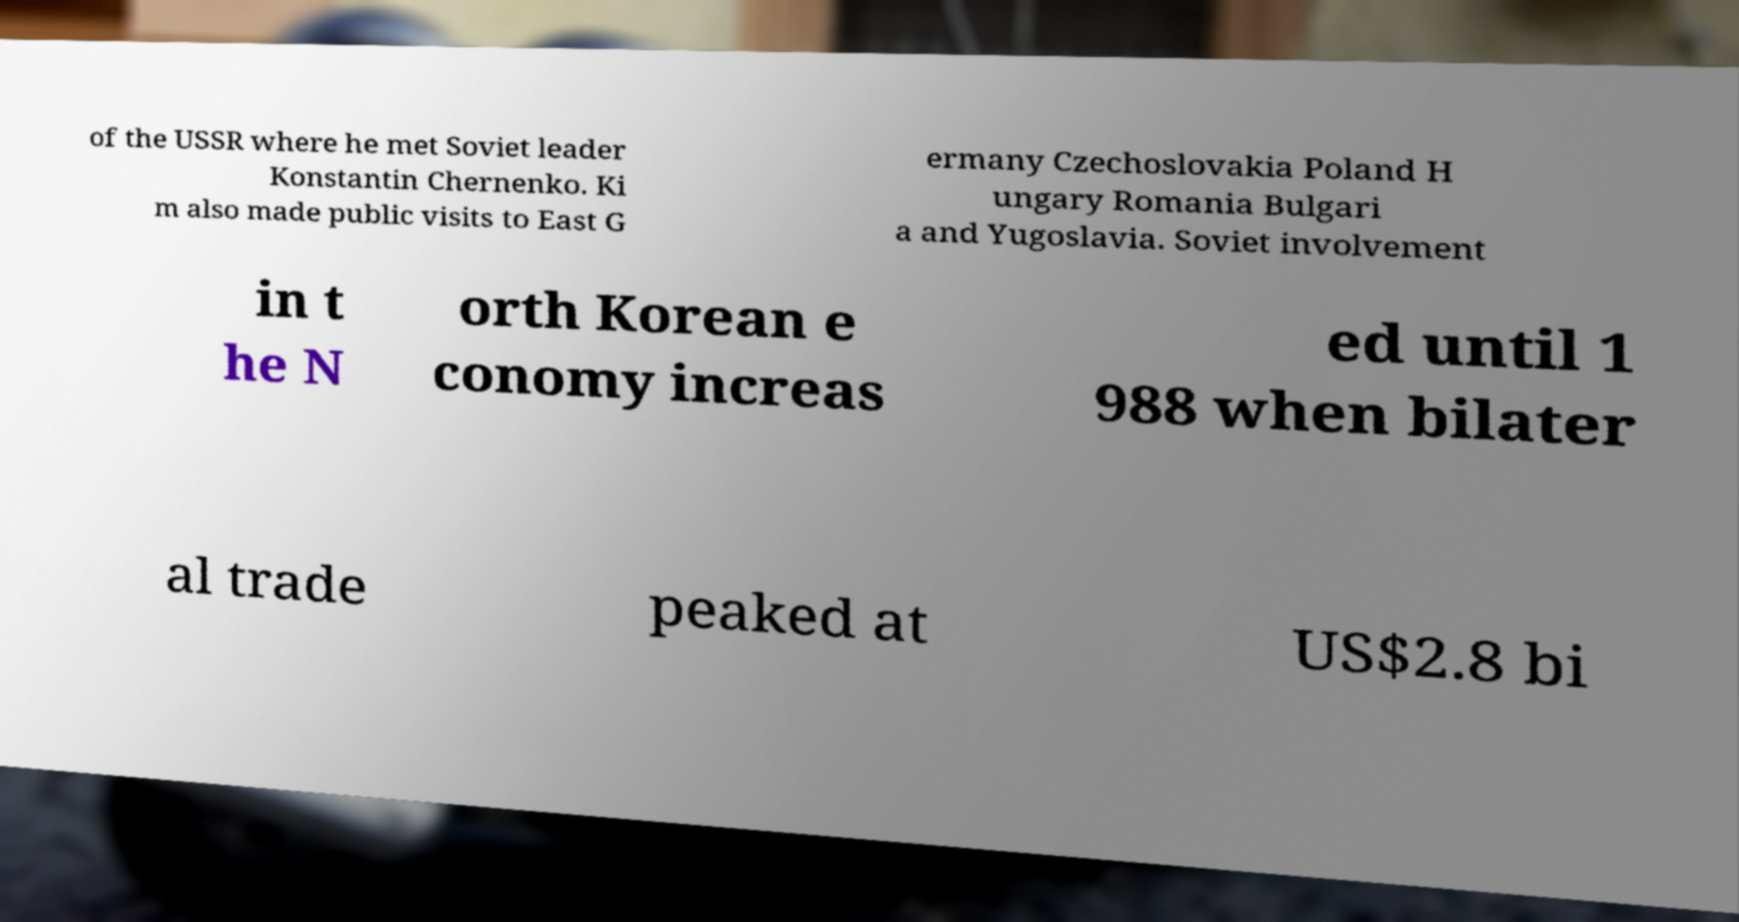For documentation purposes, I need the text within this image transcribed. Could you provide that? of the USSR where he met Soviet leader Konstantin Chernenko. Ki m also made public visits to East G ermany Czechoslovakia Poland H ungary Romania Bulgari a and Yugoslavia. Soviet involvement in t he N orth Korean e conomy increas ed until 1 988 when bilater al trade peaked at US$2.8 bi 